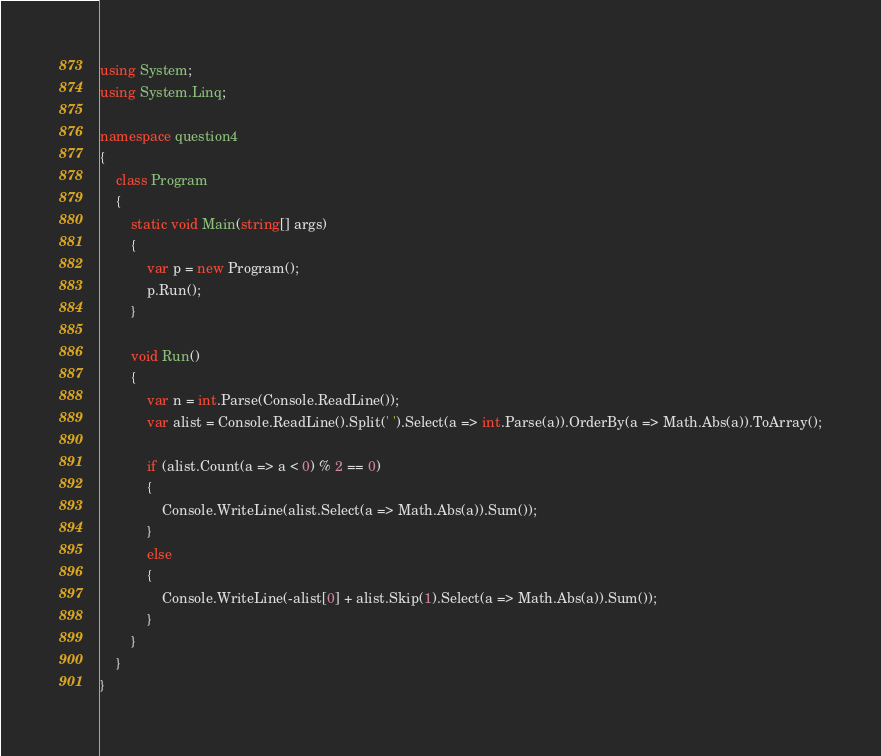Convert code to text. <code><loc_0><loc_0><loc_500><loc_500><_C#_>using System;
using System.Linq;

namespace question4
{
    class Program
    {
        static void Main(string[] args)
        {
            var p = new Program();
            p.Run();
        }

        void Run()
        {
            var n = int.Parse(Console.ReadLine());
            var alist = Console.ReadLine().Split(' ').Select(a => int.Parse(a)).OrderBy(a => Math.Abs(a)).ToArray();

            if (alist.Count(a => a < 0) % 2 == 0)
            {
                Console.WriteLine(alist.Select(a => Math.Abs(a)).Sum());
            }
            else
            {
                Console.WriteLine(-alist[0] + alist.Skip(1).Select(a => Math.Abs(a)).Sum());
            }
        }
    }
}
</code> 